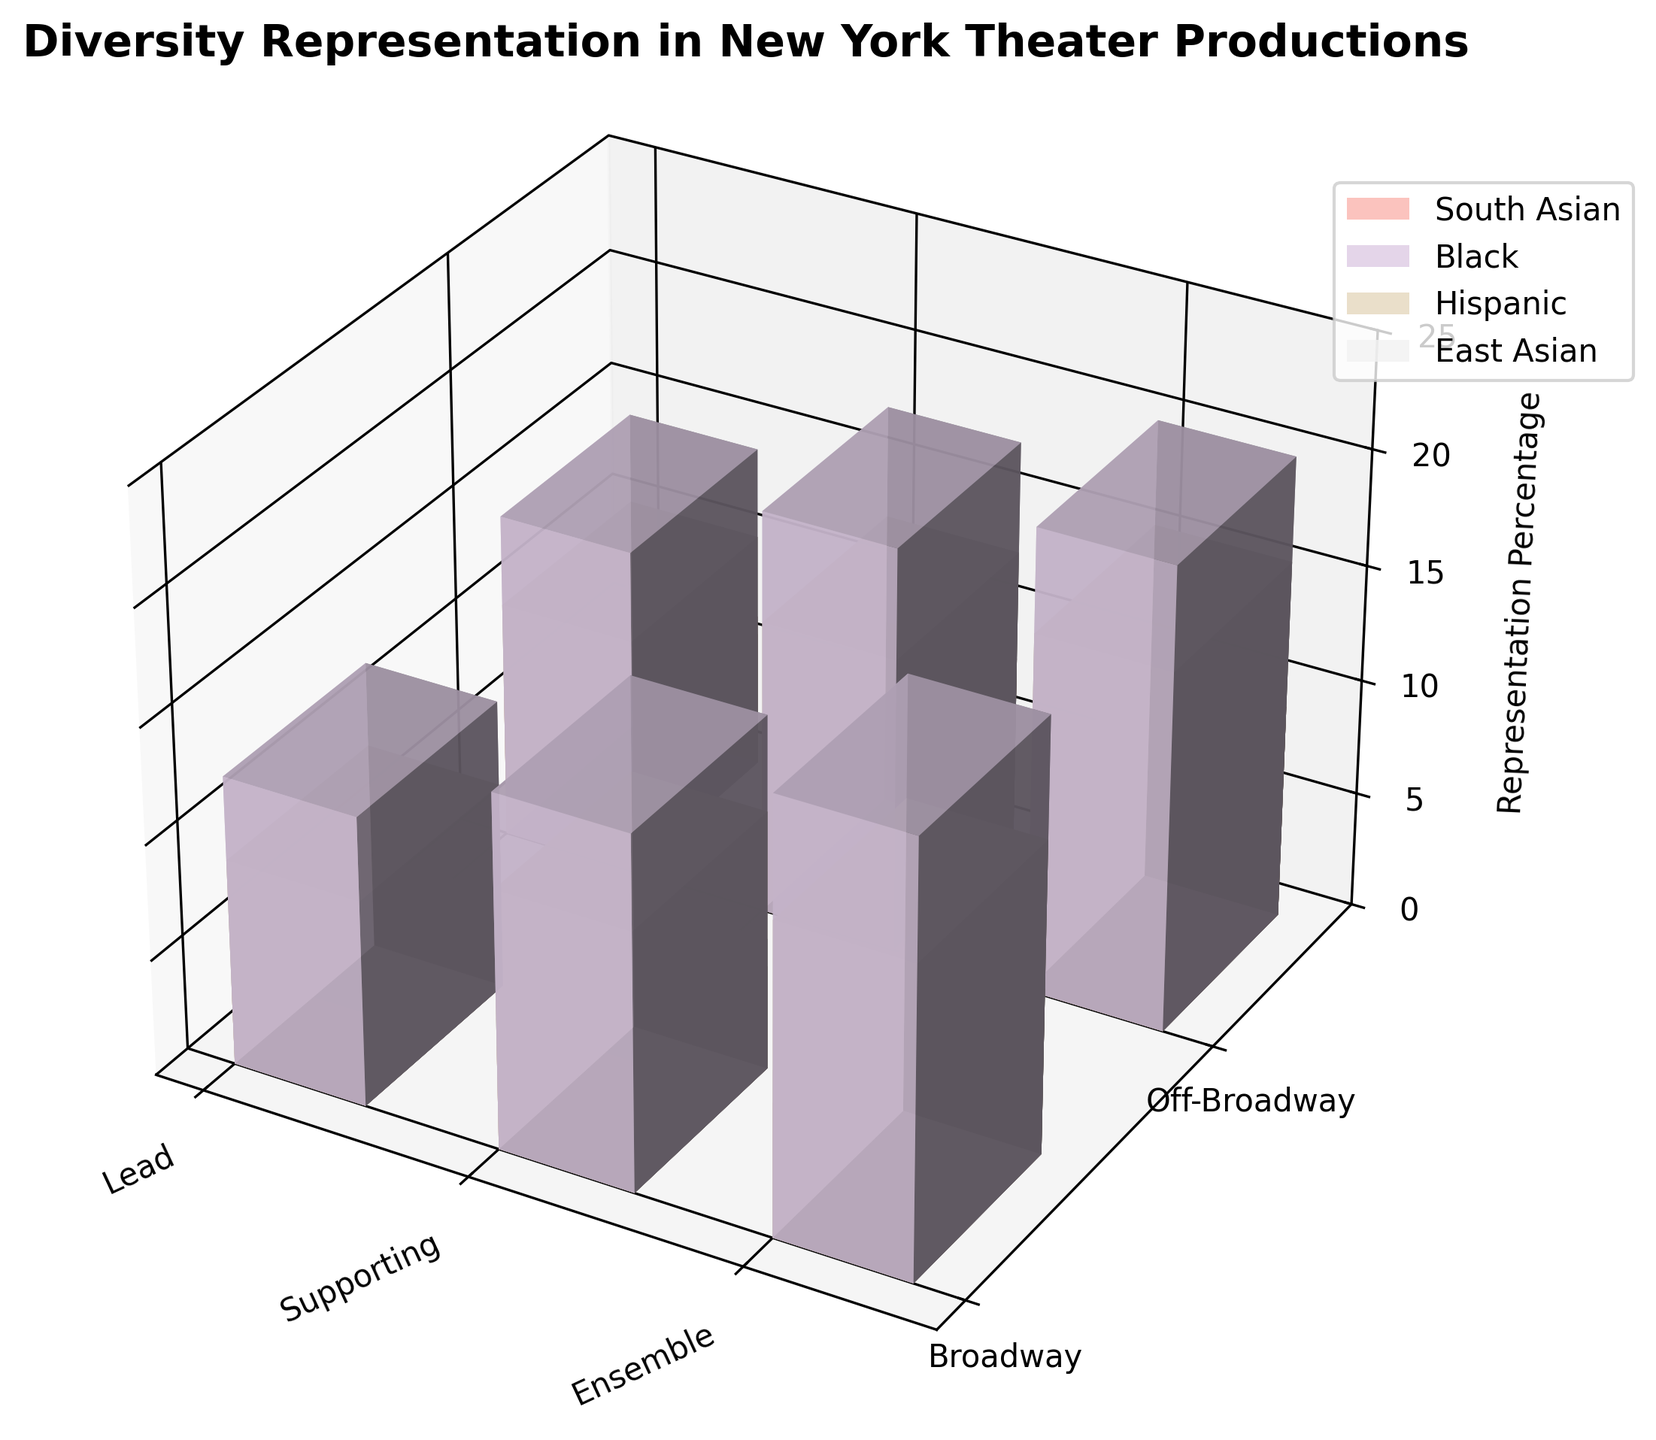What is the title of the figure? The title of the figure is displayed at the top of the plot.
Answer: Diversity Representation in New York Theater Productions How many unique ethnicities are represented in the figure? Each unique color bar represents a different ethnicity. Checking the legend, there are four unique ethnicities.
Answer: Four Which ethnicity has the highest representation percentage? Compare the height of the bars for all ethnicities. Black ethnicity has the highest bars reaching up to 20.1%.
Answer: Black What is the representation percentage of South Asians in Broadway lead roles? Find the bars for 'South Asian' and then locate the bar intersecting 'Broadway' and 'Lead' roles. The height indicates 3.2%.
Answer: 3.2% Which production size has the highest overall representation percentage for Black ethnicity? Look at the heights of bars designated with 'Black' ethnicity in different production sizes. Off-Broadway shows higher bars reaching up to 20.1%.
Answer: Off-Broadway What is the difference in representation percentage between South Asians in lead roles on Broadway and Off-Broadway? Subtract the percentage of South Asians in Broadway lead roles (3.2%) from the percentage in Off-Broadway lead roles (6.7%). The difference is 6.7 - 3.2 = 3.5%.
Answer: 3.5% Which role type has the highest average representation percentage across all ethnicities? Calculate the average height of bars for each role type across all ethnicities. Ensemble roles have the highest average representation percentage.
Answer: Ensemble Do East Asians have higher representation in supporting roles on Broadway or Off-Broadway? Compare bar heights for 'East Asian' in 'Supporting' roles on Broadway (5.7%) and Off-Broadway (7.5%). Off-Broadway is higher.
Answer: Off-Broadway Which ethnicity has the least representation in Off-Broadway productions? Identify the ethnicity with the smallest bar heights in Off-Broadway. South Asian has the smallest with the highest being only up to 9.3%.
Answer: South Asian 